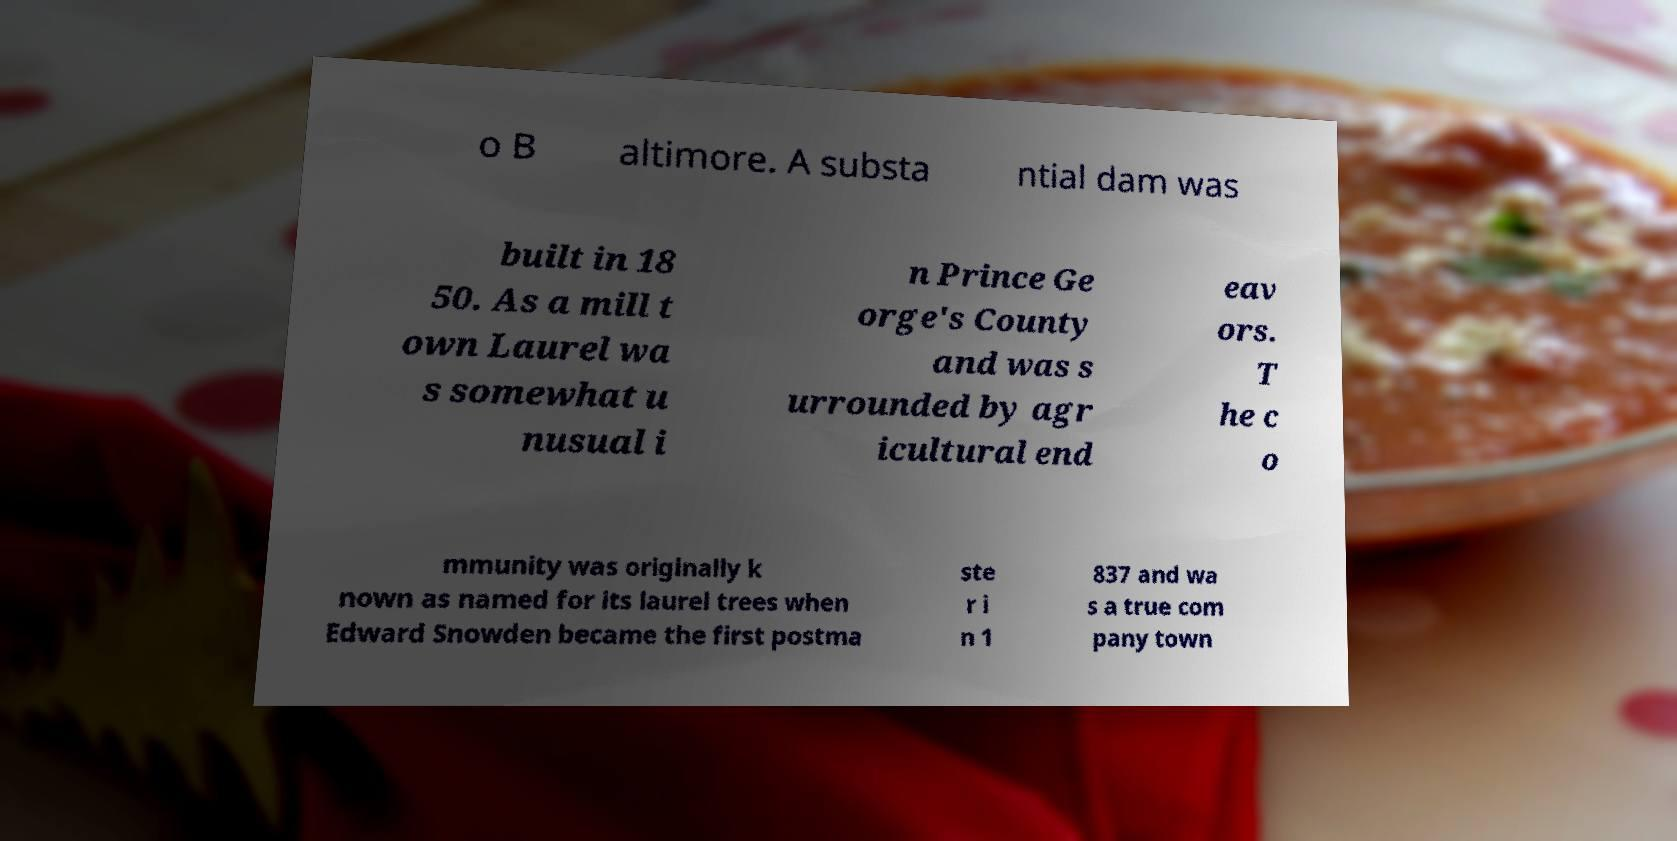Please identify and transcribe the text found in this image. o B altimore. A substa ntial dam was built in 18 50. As a mill t own Laurel wa s somewhat u nusual i n Prince Ge orge's County and was s urrounded by agr icultural end eav ors. T he c o mmunity was originally k nown as named for its laurel trees when Edward Snowden became the first postma ste r i n 1 837 and wa s a true com pany town 